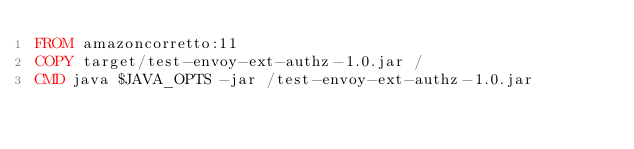<code> <loc_0><loc_0><loc_500><loc_500><_Dockerfile_>FROM amazoncorretto:11
COPY target/test-envoy-ext-authz-1.0.jar /
CMD java $JAVA_OPTS -jar /test-envoy-ext-authz-1.0.jar
</code> 